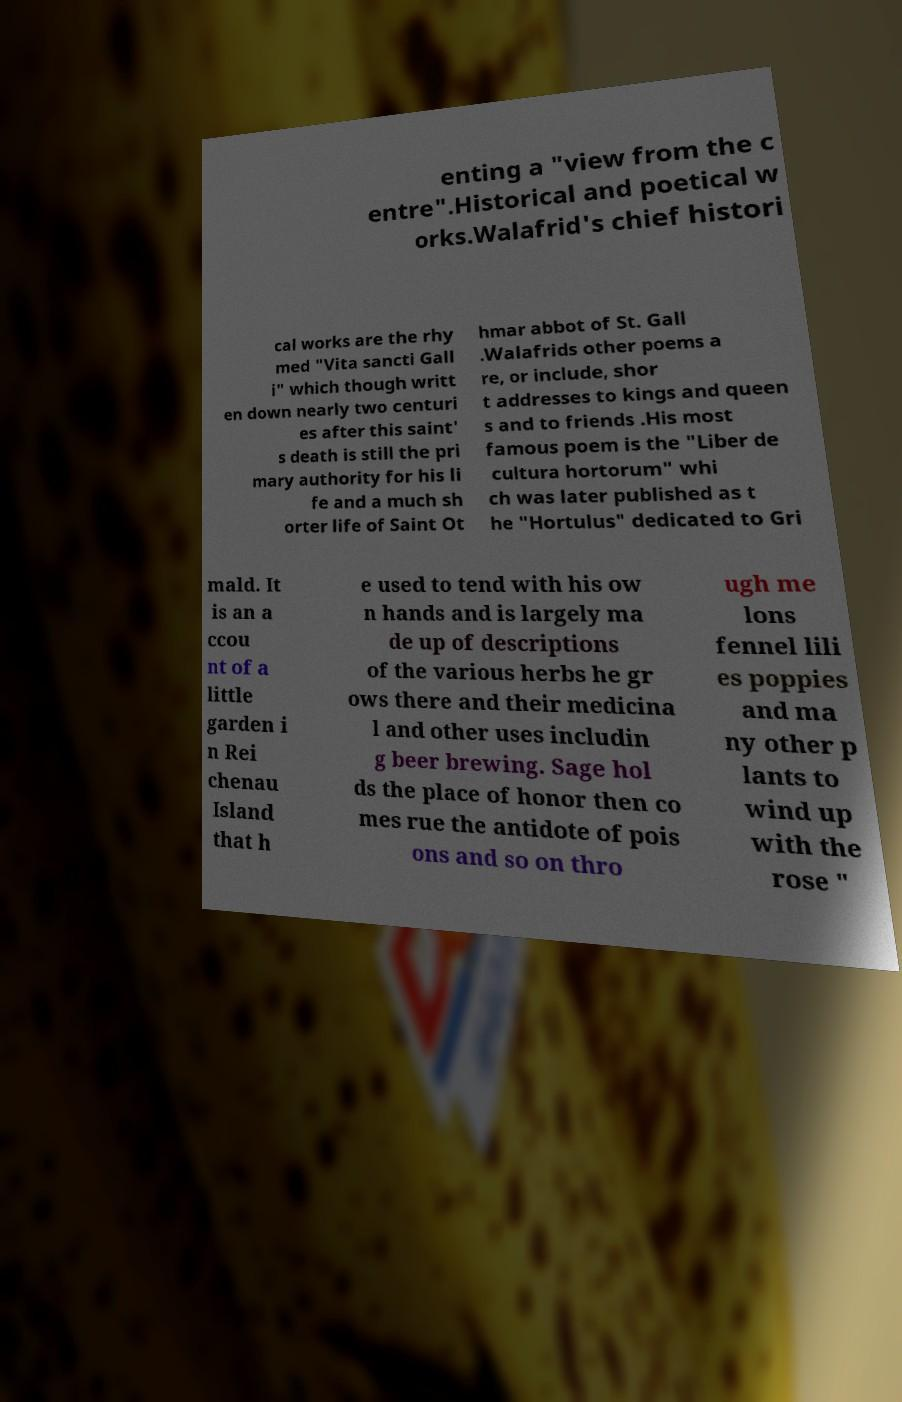There's text embedded in this image that I need extracted. Can you transcribe it verbatim? enting a "view from the c entre".Historical and poetical w orks.Walafrid's chief histori cal works are the rhy med "Vita sancti Gall i" which though writt en down nearly two centuri es after this saint' s death is still the pri mary authority for his li fe and a much sh orter life of Saint Ot hmar abbot of St. Gall .Walafrids other poems a re, or include, shor t addresses to kings and queen s and to friends .His most famous poem is the "Liber de cultura hortorum" whi ch was later published as t he "Hortulus" dedicated to Gri mald. It is an a ccou nt of a little garden i n Rei chenau Island that h e used to tend with his ow n hands and is largely ma de up of descriptions of the various herbs he gr ows there and their medicina l and other uses includin g beer brewing. Sage hol ds the place of honor then co mes rue the antidote of pois ons and so on thro ugh me lons fennel lili es poppies and ma ny other p lants to wind up with the rose " 